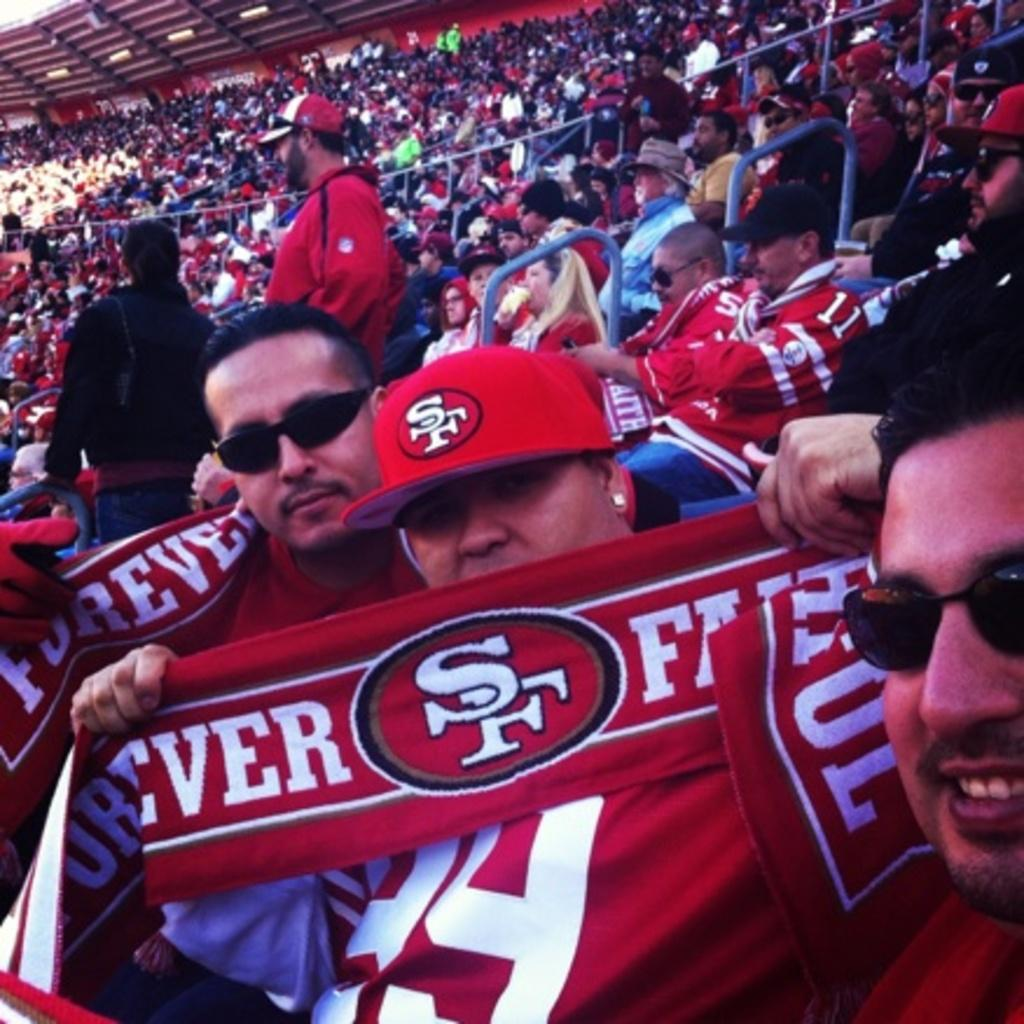<image>
Give a short and clear explanation of the subsequent image. Man holding a jersey which says SF on it. 